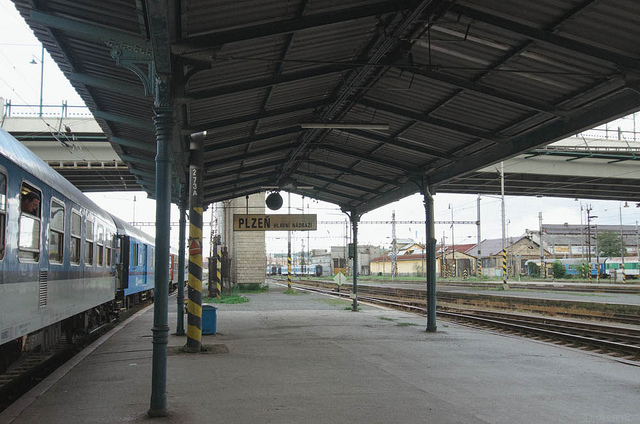Please transcribe the text in this image. 273A PLZEN 